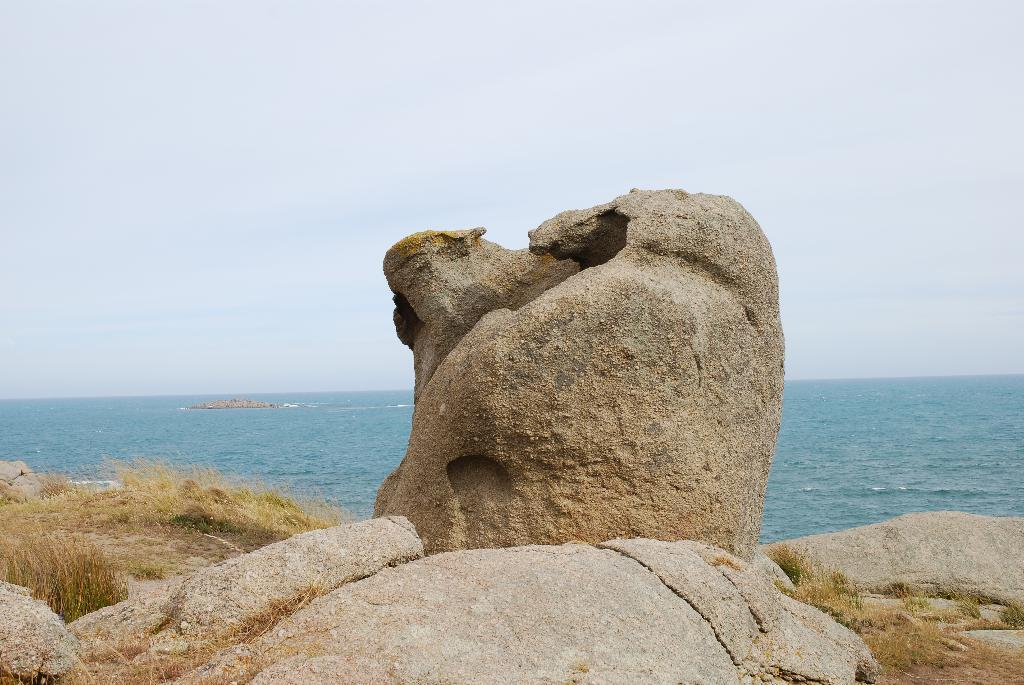What type of environment is depicted in the image? The image is an outside view. What can be seen at the bottom of the image? There are rocks and grass at the bottom of the image. What is visible in the background of the image? There is an ocean in the background of the image. What is visible at the top of the image? The sky is visible at the top of the image. What type of skirt is the rock wearing in the image? There are no rocks wearing skirts in the image; rocks are inanimate objects and do not wear clothing. 